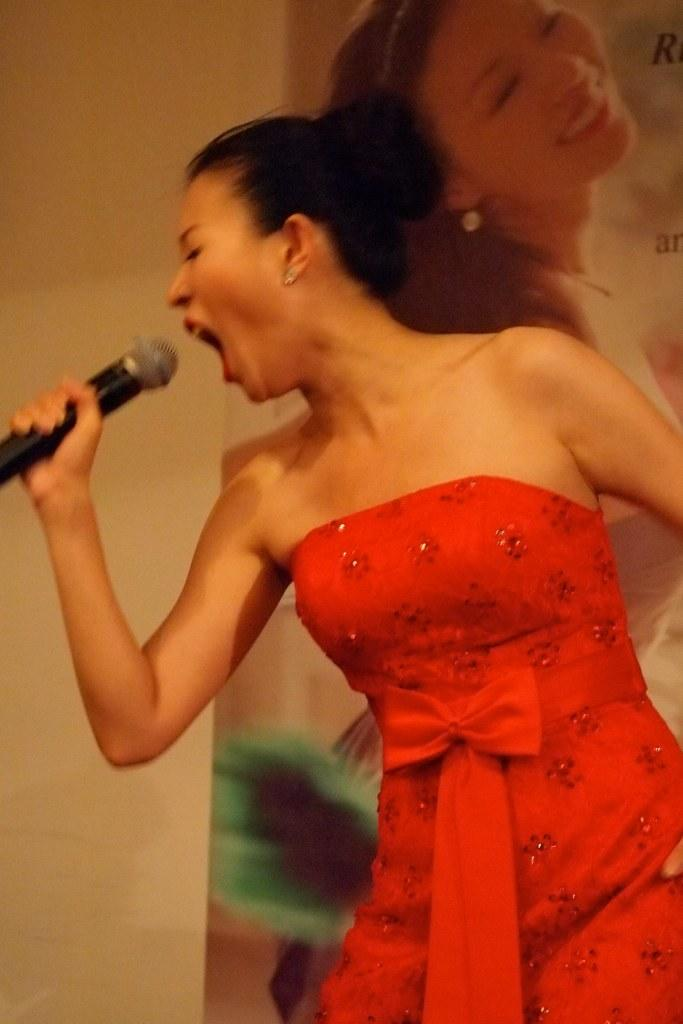What is the main subject in the foreground of the image? There is a woman standing in the foreground of the image. What is the woman doing in the image? The woman is singing. What can be seen in the background of the image? There is a poster in the background of the image. What is depicted on the poster? The poster depicts a woman smiling. What type of comfort can be seen being offered to the protesters in the image? There is no mention of protesters or comfort in the image; it features a woman singing and a poster with a smiling woman. 